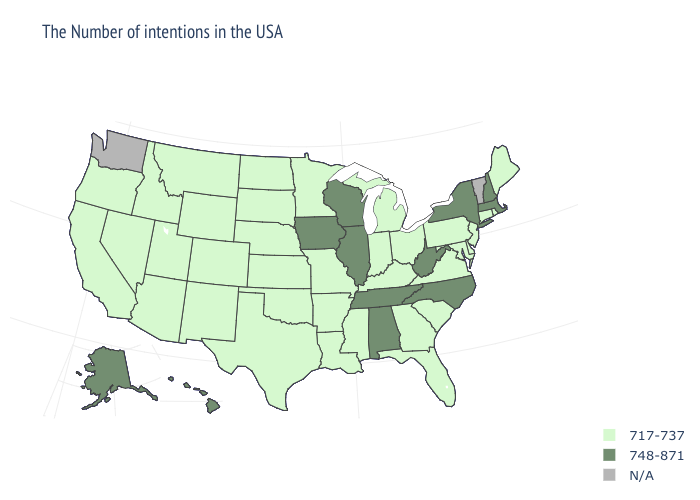What is the value of Maine?
Quick response, please. 717-737. What is the lowest value in the Northeast?
Short answer required. 717-737. What is the value of Ohio?
Write a very short answer. 717-737. What is the lowest value in the Northeast?
Answer briefly. 717-737. Which states have the lowest value in the Northeast?
Be succinct. Maine, Rhode Island, Connecticut, New Jersey, Pennsylvania. Name the states that have a value in the range N/A?
Keep it brief. Vermont, Washington. Among the states that border Texas , which have the lowest value?
Concise answer only. Louisiana, Arkansas, Oklahoma, New Mexico. Name the states that have a value in the range 748-871?
Short answer required. Massachusetts, New Hampshire, New York, North Carolina, West Virginia, Alabama, Tennessee, Wisconsin, Illinois, Iowa, Alaska, Hawaii. Name the states that have a value in the range 717-737?
Quick response, please. Maine, Rhode Island, Connecticut, New Jersey, Delaware, Maryland, Pennsylvania, Virginia, South Carolina, Ohio, Florida, Georgia, Michigan, Kentucky, Indiana, Mississippi, Louisiana, Missouri, Arkansas, Minnesota, Kansas, Nebraska, Oklahoma, Texas, South Dakota, North Dakota, Wyoming, Colorado, New Mexico, Utah, Montana, Arizona, Idaho, Nevada, California, Oregon. Name the states that have a value in the range 717-737?
Keep it brief. Maine, Rhode Island, Connecticut, New Jersey, Delaware, Maryland, Pennsylvania, Virginia, South Carolina, Ohio, Florida, Georgia, Michigan, Kentucky, Indiana, Mississippi, Louisiana, Missouri, Arkansas, Minnesota, Kansas, Nebraska, Oklahoma, Texas, South Dakota, North Dakota, Wyoming, Colorado, New Mexico, Utah, Montana, Arizona, Idaho, Nevada, California, Oregon. Which states have the highest value in the USA?
Quick response, please. Massachusetts, New Hampshire, New York, North Carolina, West Virginia, Alabama, Tennessee, Wisconsin, Illinois, Iowa, Alaska, Hawaii. Name the states that have a value in the range 717-737?
Keep it brief. Maine, Rhode Island, Connecticut, New Jersey, Delaware, Maryland, Pennsylvania, Virginia, South Carolina, Ohio, Florida, Georgia, Michigan, Kentucky, Indiana, Mississippi, Louisiana, Missouri, Arkansas, Minnesota, Kansas, Nebraska, Oklahoma, Texas, South Dakota, North Dakota, Wyoming, Colorado, New Mexico, Utah, Montana, Arizona, Idaho, Nevada, California, Oregon. What is the value of New Mexico?
Quick response, please. 717-737. 